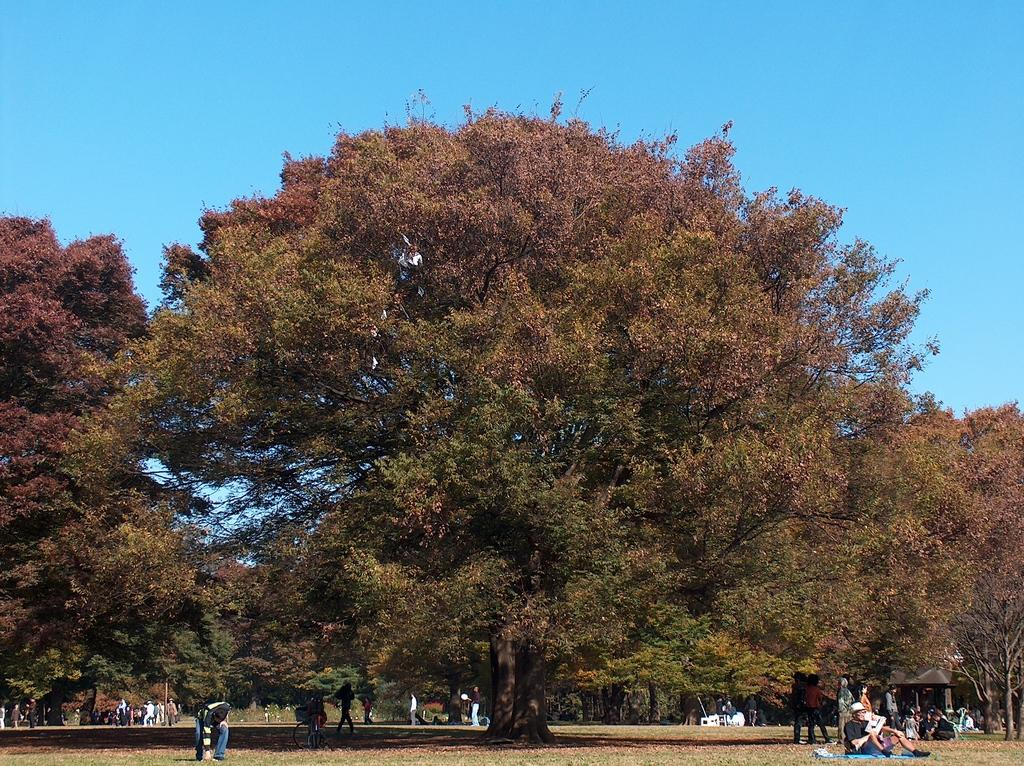What type of vegetation can be seen in the image? There are trees in the image. Who or what is present in the image besides the trees? There are people in the image. What is visible at the top of the image? The sky is visible at the top of the image. Where is the camera located in the image? There is no camera present in the image. What type of market can be seen in the image? There is no market present in the image. 